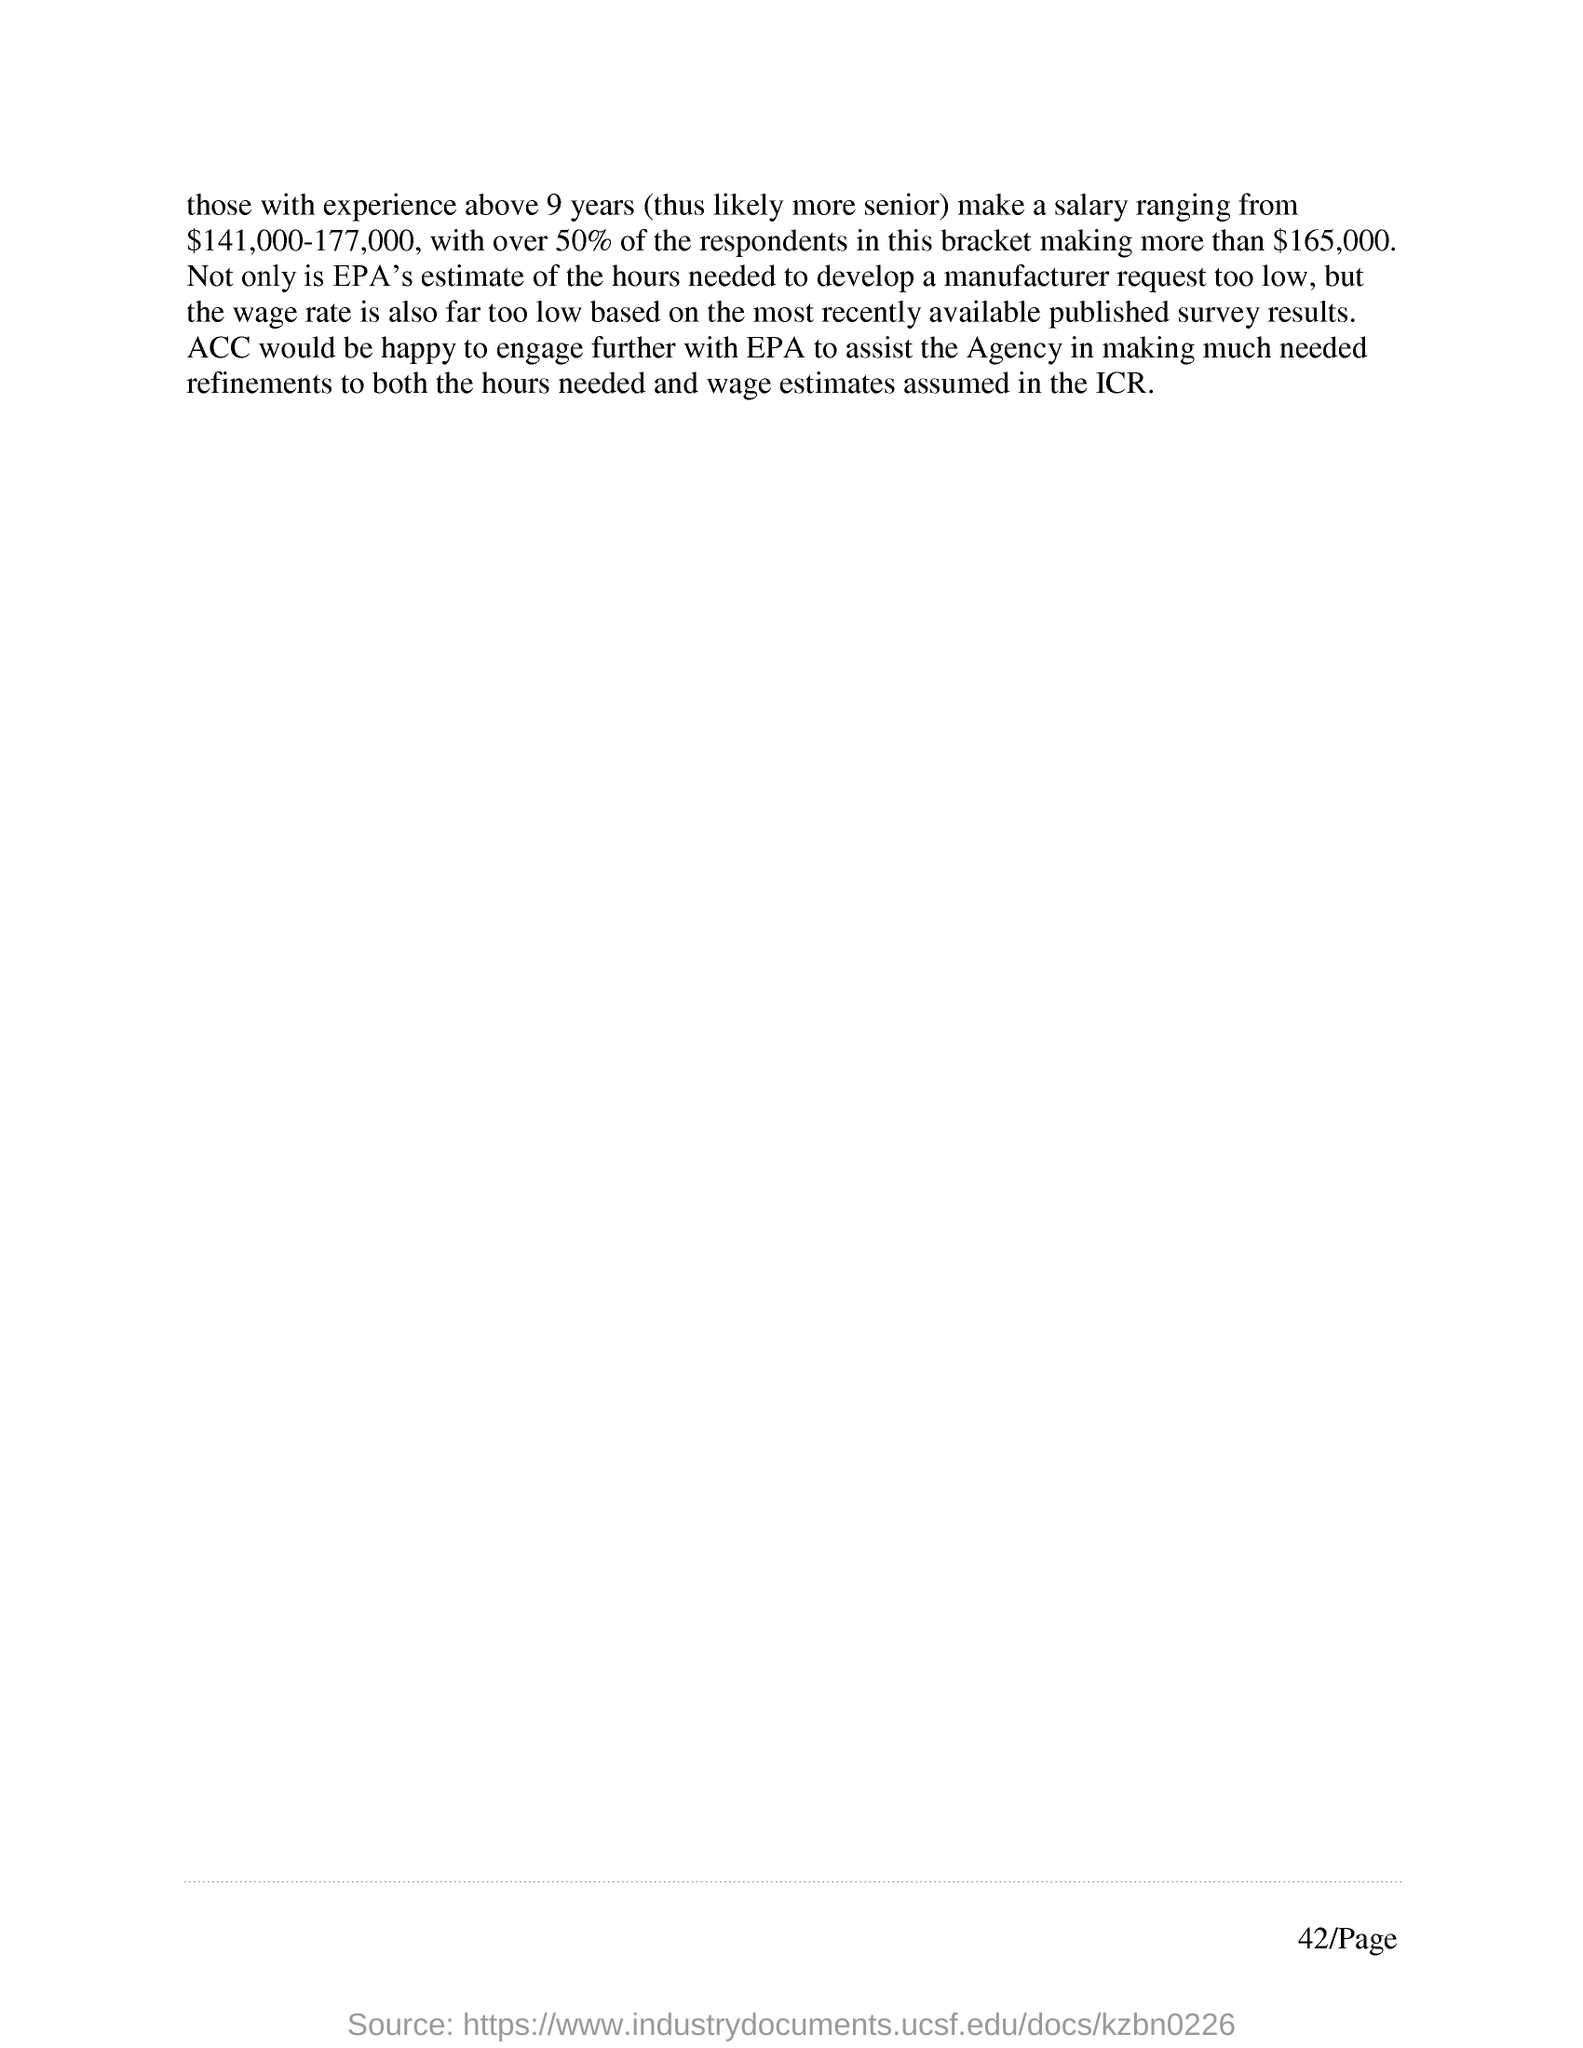Highlight a few significant elements in this photo. Over 50% of the respondents in the salary range of $144,000-$177,000 make $165,000 or more, according to the survey. The average salary for individuals with experience exceeding 9 years is estimated to range between $141,000 and $177,000 per year. 